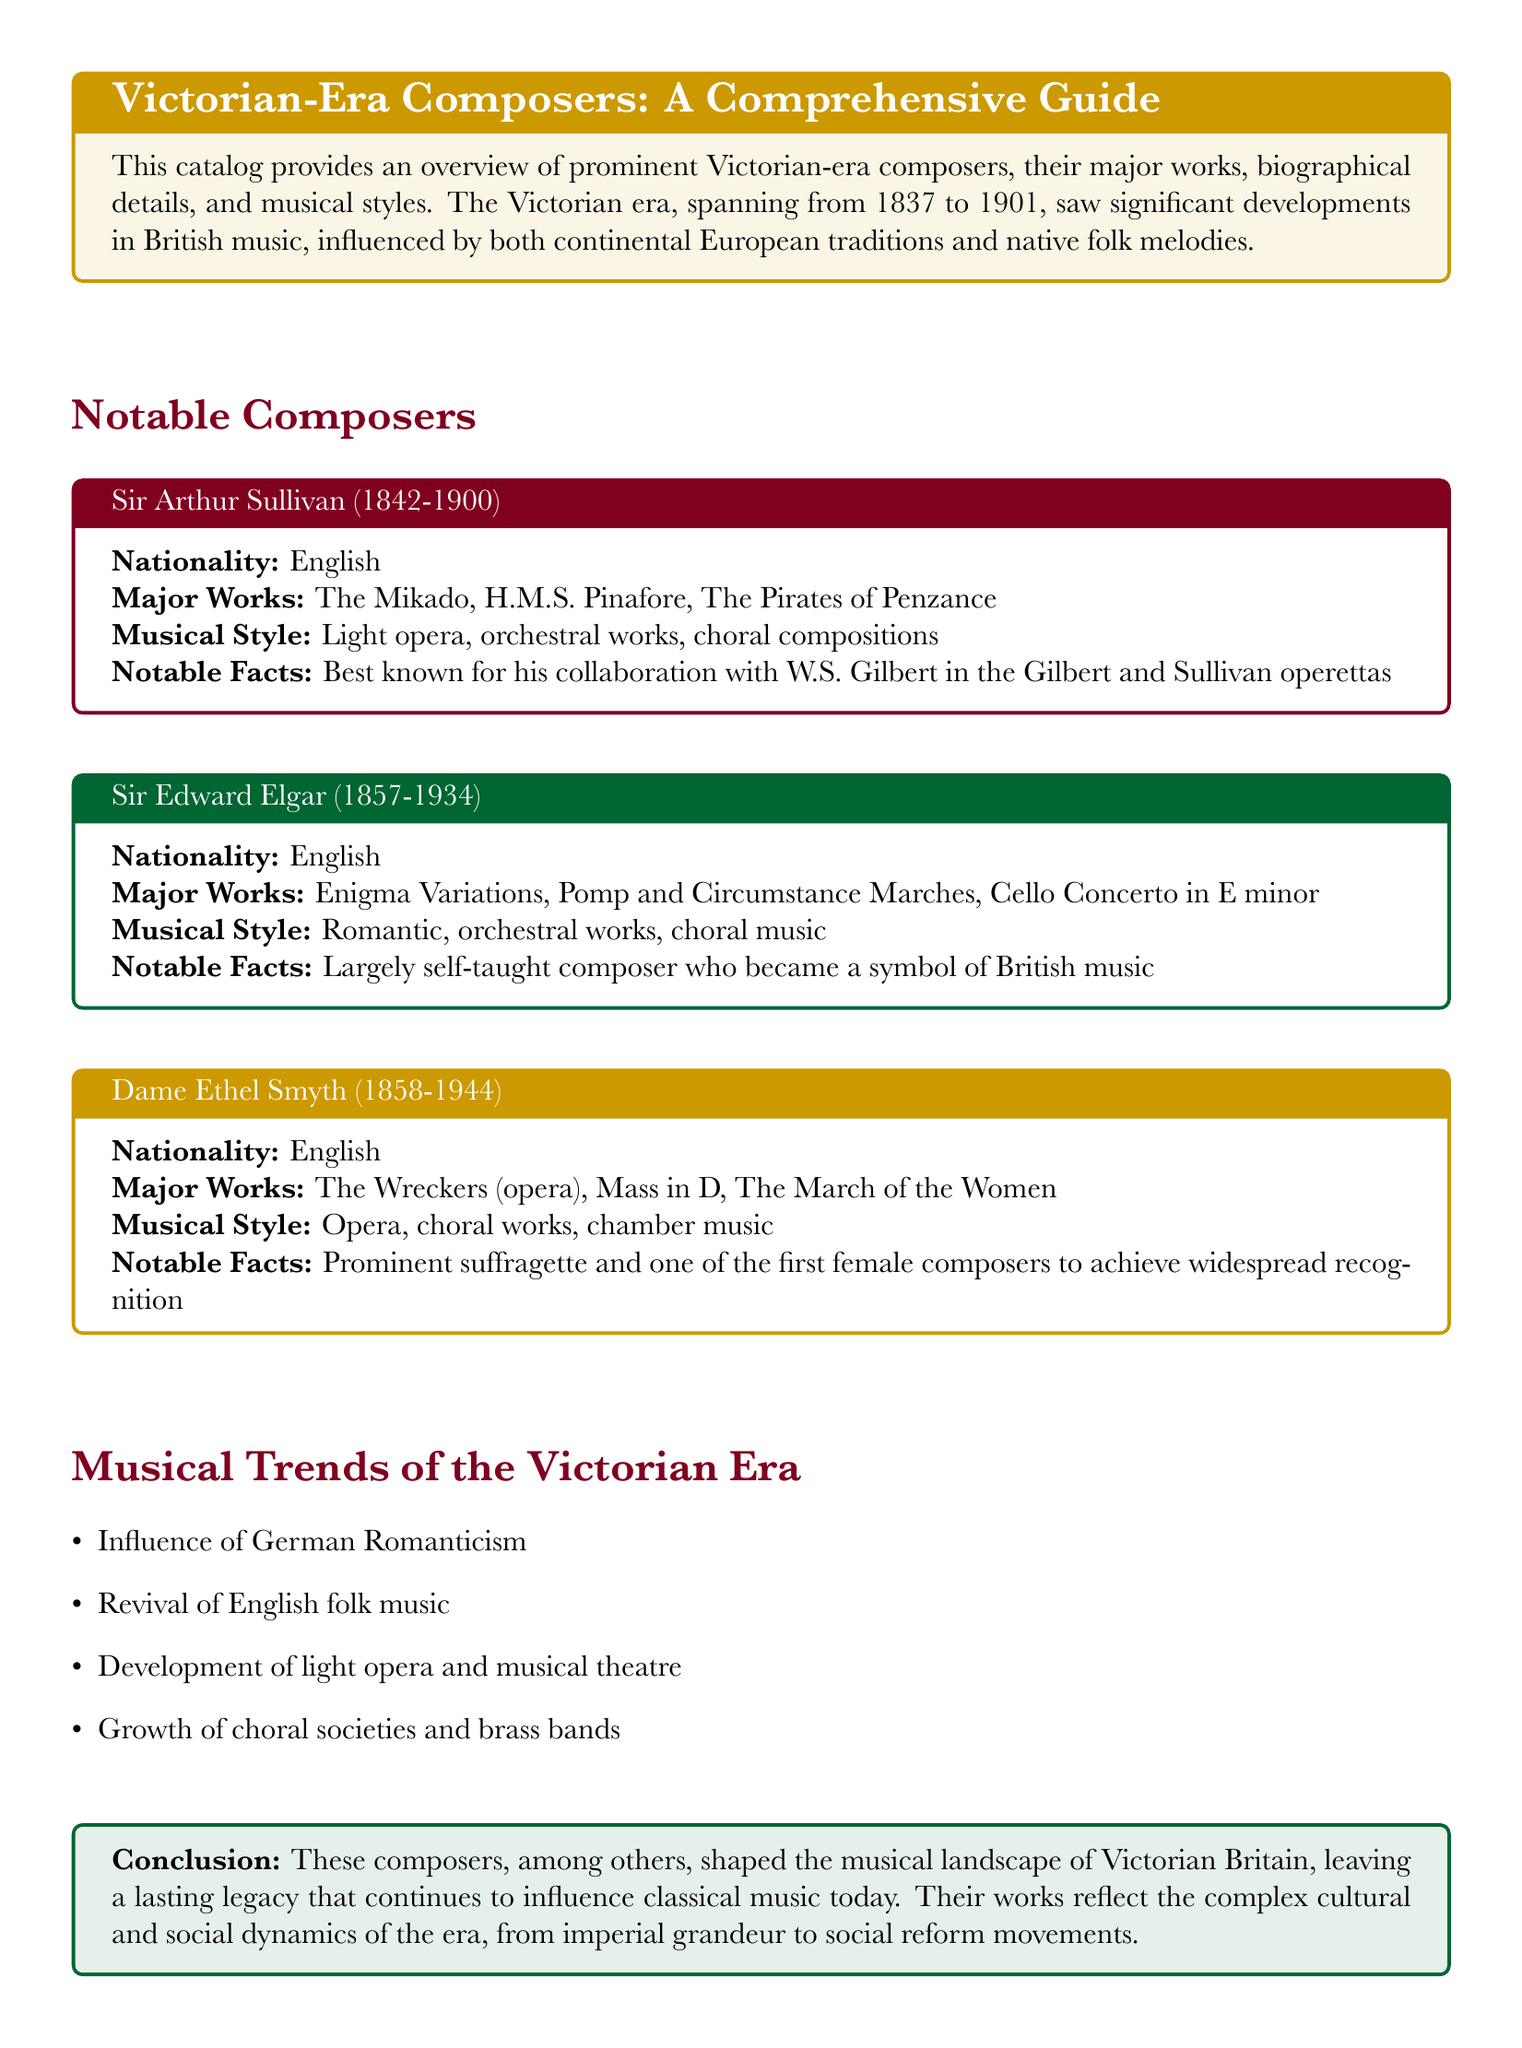what is the nationality of Sir Arthur Sullivan? The document explicitly states that Sir Arthur Sullivan is English.
Answer: English which composer is known for the opera "The Wreckers"? The document mentions that Dame Ethel Smyth is known for "The Wreckers".
Answer: Dame Ethel Smyth how many Pomp and Circumstance Marches did Sir Edward Elgar compose? The document lists "Pomp and Circumstance Marches" as one of his major works without specifying the number, but it is known there are five.
Answer: Five what musical style is associated with Dame Ethel Smyth? The document categorizes her musical style under opera, choral works, and chamber music.
Answer: Opera, choral works, chamber music what significant cultural influence is noted in the Victorian era? The document mentions the influence of German Romanticism as a significant trend.
Answer: German Romanticism which famous collaboration is Sir Arthur Sullivan known for? The document states that he is best known for his collaboration with W.S. Gilbert in the Gilbert and Sullivan operettas.
Answer: W.S. Gilbert what are the major works of Sir Edward Elgar? The document lists Enigma Variations, Pomp and Circumstance Marches, and Cello Concerto in E minor as his major works.
Answer: Enigma Variations, Pomp and Circumstance Marches, Cello Concerto in E minor which musical trend emphasizes the revival of traditional music? The document includes the revival of English folk music as a prominent musical trend of the Victorian era.
Answer: Revival of English folk music who is noted as a prominent suffragette among the composers? The document states that Dame Ethel Smyth was a prominent suffragette.
Answer: Dame Ethel Smyth 